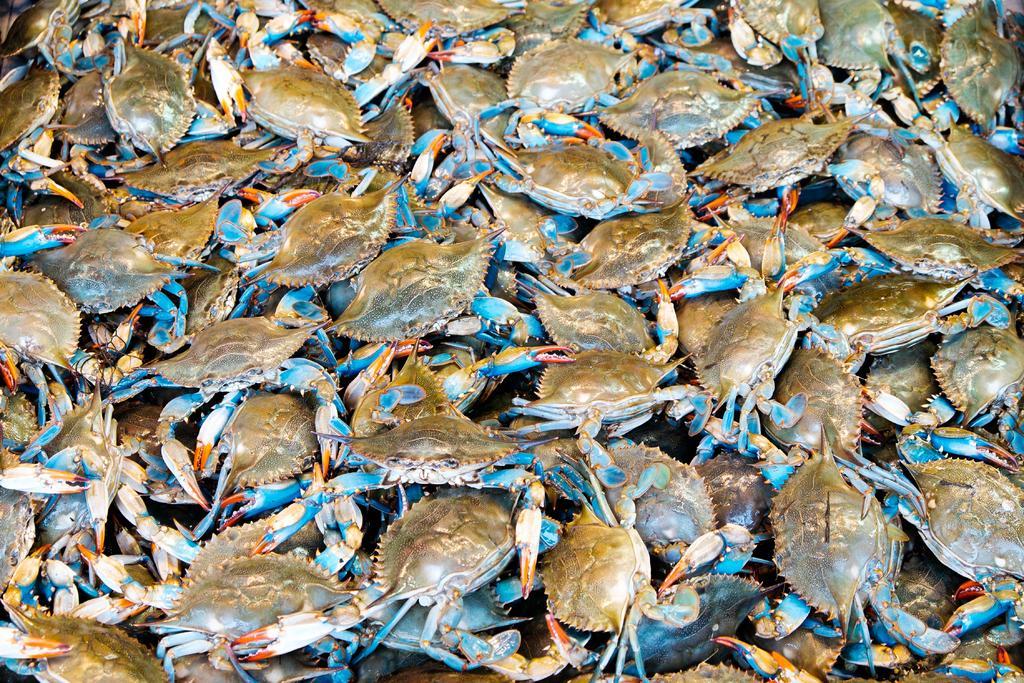How would you summarize this image in a sentence or two? In this image there are crabs. 